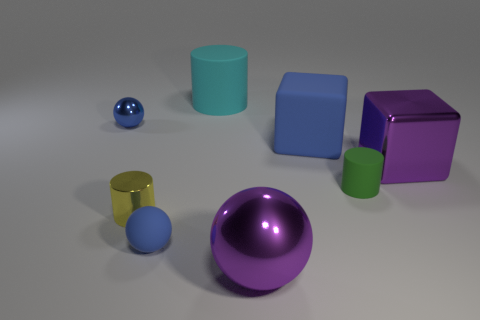Is the shape of the green matte thing the same as the metal thing that is to the left of the small yellow metal thing?
Offer a very short reply. No. Are there an equal number of small green things that are to the right of the yellow cylinder and tiny blue matte balls?
Offer a terse response. Yes. What number of things are small purple rubber blocks or metal balls that are to the left of the metallic cylinder?
Offer a terse response. 1. Is there a tiny green matte object that has the same shape as the large blue thing?
Make the answer very short. No. Are there an equal number of blue rubber cubes that are in front of the small yellow object and small cylinders behind the big purple cube?
Your response must be concise. Yes. Is there anything else that has the same size as the purple ball?
Your answer should be compact. Yes. How many purple objects are either metallic things or metal cubes?
Offer a very short reply. 2. How many metal balls have the same size as the cyan matte cylinder?
Keep it short and to the point. 1. There is a thing that is behind the green cylinder and to the right of the matte block; what is its color?
Offer a very short reply. Purple. Are there more small cylinders that are behind the cyan rubber thing than large gray balls?
Make the answer very short. No. 